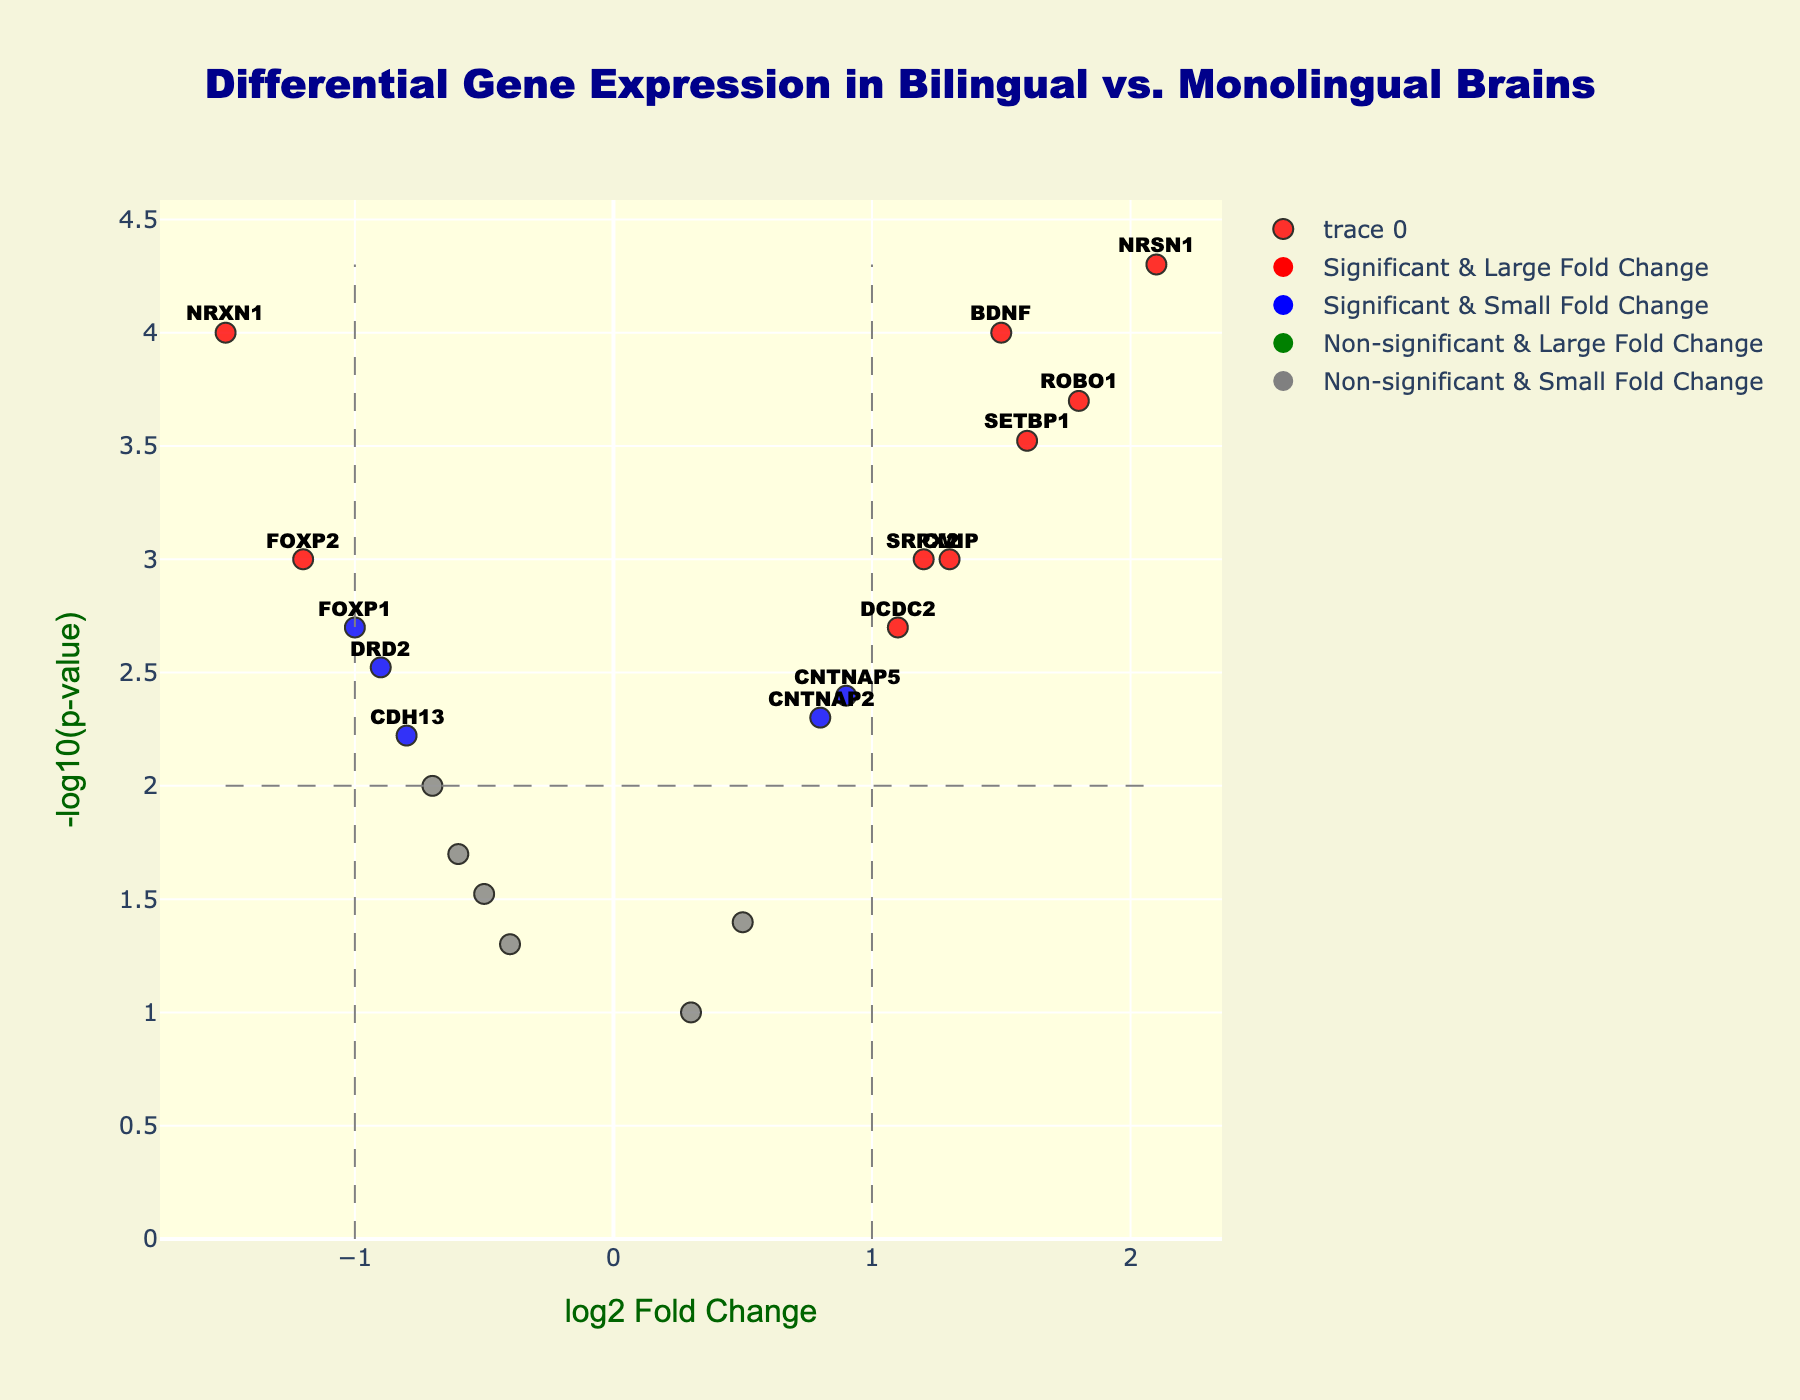Which gene shows the greatest log2 fold change? By examining the x-axis for the highest absolute log2 fold change value (x-axis extremities), identify the gene.
Answer: NRSN1 (2.1) What does the y-axis represent in this plot? Read the y-axis title in the figure.
Answer: -log10(p-value) How many genes are classified as significant with a large fold change? Look for data points in red color, which indicates significant genes with a large fold change.
Answer: 5 Which gene is both significant and has a log2 fold change above 1? Identify red-colored points to see which one has a log2 fold change greater than 1 by referring to the x-axis.
Answer: NRSN1, BDNF, ROBO1, SETBP1, CMIP What is the log2 fold change and p-value of FOXP2? Hover over or refer to FOXP2 in the plot to get its fold change and p-value.
Answer: -1.2, 0.001 How many genes are marked as non-significant yet have a large fold change? Look for green-colored points indicating non-significant but with large fold changes.
Answer: 0 Why is SRPX2 colored red in the plot? Check the criteria for red color: significant and large fold change, evaluate SRPX2 with fold change and p-value.
Answer: Its p-value is 0.001 (significant), and its log2 fold change is 1.2 (above 1) Which has a lower p-value, BDNF or NRXN1? Compare their y-values due to -log10(p-value): higher y-value means lower p-value.
Answer: NRSN1 What thresholds are indicated by the dashed lines? Identify lines and their positions corresponding to log2-fold change (x-axis) and -log10(p-value) (y-axis) thresholds.
Answer: log2 fold change ±1, p-value 0.01 Are there more significant genes with a small fold change or non-significant genes with a small fold change? Count blue and grey points. Blue means significant & small fold change; grey means non-significant & small fold change.
Answer: More non-significant genes with a small fold change (grey points) 